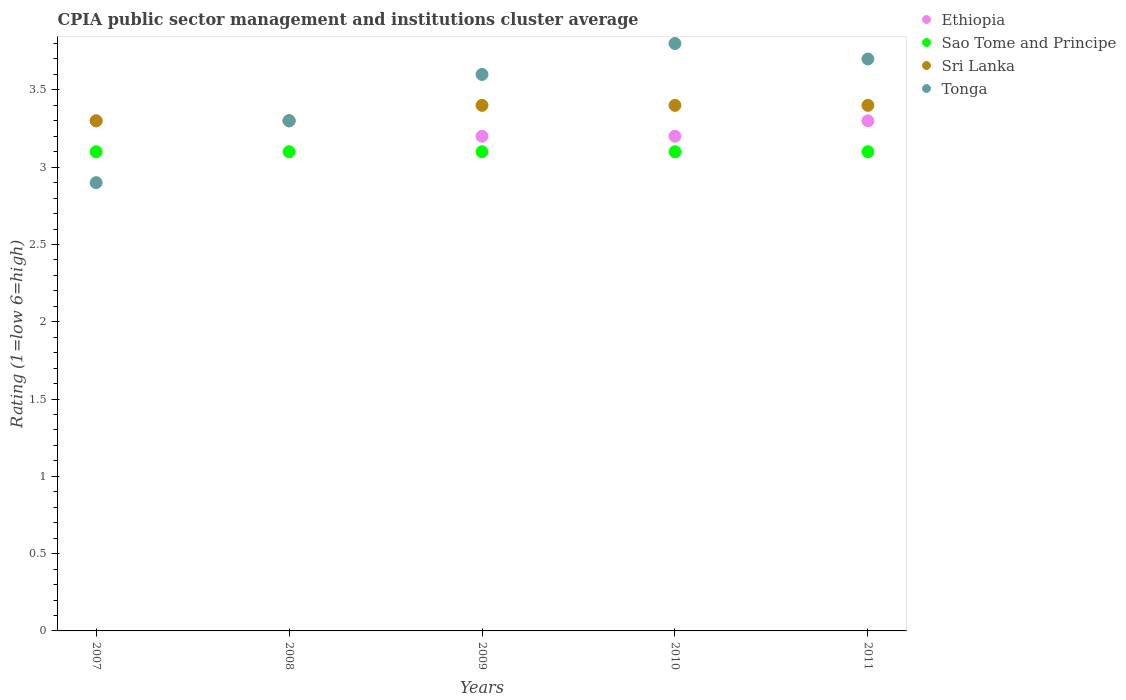How many different coloured dotlines are there?
Make the answer very short. 4. What is the CPIA rating in Sao Tome and Principe in 2007?
Make the answer very short. 3.1. Across all years, what is the maximum CPIA rating in Ethiopia?
Your response must be concise. 3.3. In which year was the CPIA rating in Sri Lanka maximum?
Provide a short and direct response. 2009. What is the difference between the CPIA rating in Sao Tome and Principe in 2010 and that in 2011?
Your answer should be compact. 0. What is the difference between the CPIA rating in Sri Lanka in 2010 and the CPIA rating in Sao Tome and Principe in 2007?
Provide a short and direct response. 0.3. What is the average CPIA rating in Tonga per year?
Offer a very short reply. 3.46. In the year 2007, what is the difference between the CPIA rating in Sao Tome and Principe and CPIA rating in Sri Lanka?
Your answer should be compact. -0.2. In how many years, is the CPIA rating in Sri Lanka greater than 1.4?
Give a very brief answer. 5. What is the ratio of the CPIA rating in Tonga in 2007 to that in 2009?
Offer a very short reply. 0.81. Is the CPIA rating in Sri Lanka in 2007 less than that in 2010?
Keep it short and to the point. Yes. What is the difference between the highest and the lowest CPIA rating in Ethiopia?
Your response must be concise. 0.1. Is the sum of the CPIA rating in Tonga in 2008 and 2011 greater than the maximum CPIA rating in Ethiopia across all years?
Your answer should be very brief. Yes. Is it the case that in every year, the sum of the CPIA rating in Sri Lanka and CPIA rating in Sao Tome and Principe  is greater than the CPIA rating in Tonga?
Keep it short and to the point. Yes. Is the CPIA rating in Ethiopia strictly greater than the CPIA rating in Sri Lanka over the years?
Keep it short and to the point. No. Is the CPIA rating in Sri Lanka strictly less than the CPIA rating in Tonga over the years?
Keep it short and to the point. No. How many dotlines are there?
Give a very brief answer. 4. What is the difference between two consecutive major ticks on the Y-axis?
Your response must be concise. 0.5. Where does the legend appear in the graph?
Make the answer very short. Top right. How are the legend labels stacked?
Your answer should be very brief. Vertical. What is the title of the graph?
Your answer should be very brief. CPIA public sector management and institutions cluster average. Does "Least developed countries" appear as one of the legend labels in the graph?
Make the answer very short. No. What is the Rating (1=low 6=high) in Tonga in 2007?
Provide a succinct answer. 2.9. What is the Rating (1=low 6=high) of Sri Lanka in 2008?
Make the answer very short. 3.3. What is the Rating (1=low 6=high) in Sri Lanka in 2009?
Your answer should be very brief. 3.4. What is the Rating (1=low 6=high) of Ethiopia in 2011?
Ensure brevity in your answer.  3.3. What is the Rating (1=low 6=high) of Sao Tome and Principe in 2011?
Offer a terse response. 3.1. Across all years, what is the maximum Rating (1=low 6=high) in Ethiopia?
Give a very brief answer. 3.3. Across all years, what is the maximum Rating (1=low 6=high) in Sao Tome and Principe?
Provide a short and direct response. 3.1. Across all years, what is the maximum Rating (1=low 6=high) of Sri Lanka?
Provide a succinct answer. 3.4. Across all years, what is the minimum Rating (1=low 6=high) of Ethiopia?
Make the answer very short. 3.2. Across all years, what is the minimum Rating (1=low 6=high) of Sao Tome and Principe?
Make the answer very short. 3.1. Across all years, what is the minimum Rating (1=low 6=high) of Sri Lanka?
Offer a terse response. 3.3. What is the total Rating (1=low 6=high) in Ethiopia in the graph?
Give a very brief answer. 16.3. What is the difference between the Rating (1=low 6=high) of Ethiopia in 2007 and that in 2008?
Offer a terse response. 0. What is the difference between the Rating (1=low 6=high) of Ethiopia in 2007 and that in 2009?
Your response must be concise. 0.1. What is the difference between the Rating (1=low 6=high) in Sao Tome and Principe in 2007 and that in 2009?
Make the answer very short. 0. What is the difference between the Rating (1=low 6=high) in Tonga in 2007 and that in 2009?
Provide a succinct answer. -0.7. What is the difference between the Rating (1=low 6=high) of Sri Lanka in 2007 and that in 2011?
Ensure brevity in your answer.  -0.1. What is the difference between the Rating (1=low 6=high) of Tonga in 2007 and that in 2011?
Offer a very short reply. -0.8. What is the difference between the Rating (1=low 6=high) in Ethiopia in 2008 and that in 2009?
Your answer should be very brief. 0.1. What is the difference between the Rating (1=low 6=high) in Sao Tome and Principe in 2008 and that in 2009?
Offer a terse response. 0. What is the difference between the Rating (1=low 6=high) of Sri Lanka in 2008 and that in 2009?
Ensure brevity in your answer.  -0.1. What is the difference between the Rating (1=low 6=high) in Tonga in 2008 and that in 2009?
Make the answer very short. -0.3. What is the difference between the Rating (1=low 6=high) in Sao Tome and Principe in 2008 and that in 2010?
Offer a terse response. 0. What is the difference between the Rating (1=low 6=high) of Sri Lanka in 2008 and that in 2011?
Your answer should be very brief. -0.1. What is the difference between the Rating (1=low 6=high) of Ethiopia in 2009 and that in 2010?
Your response must be concise. 0. What is the difference between the Rating (1=low 6=high) of Sao Tome and Principe in 2009 and that in 2010?
Offer a terse response. 0. What is the difference between the Rating (1=low 6=high) of Sri Lanka in 2009 and that in 2010?
Offer a terse response. 0. What is the difference between the Rating (1=low 6=high) of Tonga in 2009 and that in 2010?
Offer a very short reply. -0.2. What is the difference between the Rating (1=low 6=high) in Sri Lanka in 2009 and that in 2011?
Your answer should be very brief. 0. What is the difference between the Rating (1=low 6=high) of Sri Lanka in 2010 and that in 2011?
Your response must be concise. 0. What is the difference between the Rating (1=low 6=high) in Tonga in 2010 and that in 2011?
Provide a succinct answer. 0.1. What is the difference between the Rating (1=low 6=high) of Ethiopia in 2007 and the Rating (1=low 6=high) of Sri Lanka in 2008?
Give a very brief answer. 0. What is the difference between the Rating (1=low 6=high) in Sri Lanka in 2007 and the Rating (1=low 6=high) in Tonga in 2008?
Make the answer very short. 0. What is the difference between the Rating (1=low 6=high) in Ethiopia in 2007 and the Rating (1=low 6=high) in Sao Tome and Principe in 2009?
Your answer should be compact. 0.2. What is the difference between the Rating (1=low 6=high) of Ethiopia in 2007 and the Rating (1=low 6=high) of Sri Lanka in 2009?
Your answer should be compact. -0.1. What is the difference between the Rating (1=low 6=high) in Ethiopia in 2007 and the Rating (1=low 6=high) in Tonga in 2009?
Offer a very short reply. -0.3. What is the difference between the Rating (1=low 6=high) in Sao Tome and Principe in 2007 and the Rating (1=low 6=high) in Tonga in 2009?
Your answer should be very brief. -0.5. What is the difference between the Rating (1=low 6=high) in Ethiopia in 2007 and the Rating (1=low 6=high) in Sao Tome and Principe in 2010?
Your answer should be very brief. 0.2. What is the difference between the Rating (1=low 6=high) of Ethiopia in 2007 and the Rating (1=low 6=high) of Sri Lanka in 2010?
Your answer should be compact. -0.1. What is the difference between the Rating (1=low 6=high) of Ethiopia in 2007 and the Rating (1=low 6=high) of Sri Lanka in 2011?
Offer a very short reply. -0.1. What is the difference between the Rating (1=low 6=high) in Ethiopia in 2007 and the Rating (1=low 6=high) in Tonga in 2011?
Provide a succinct answer. -0.4. What is the difference between the Rating (1=low 6=high) of Sao Tome and Principe in 2007 and the Rating (1=low 6=high) of Sri Lanka in 2011?
Ensure brevity in your answer.  -0.3. What is the difference between the Rating (1=low 6=high) of Sao Tome and Principe in 2007 and the Rating (1=low 6=high) of Tonga in 2011?
Your answer should be very brief. -0.6. What is the difference between the Rating (1=low 6=high) in Ethiopia in 2008 and the Rating (1=low 6=high) in Sao Tome and Principe in 2009?
Offer a very short reply. 0.2. What is the difference between the Rating (1=low 6=high) in Ethiopia in 2008 and the Rating (1=low 6=high) in Sri Lanka in 2009?
Ensure brevity in your answer.  -0.1. What is the difference between the Rating (1=low 6=high) of Sao Tome and Principe in 2008 and the Rating (1=low 6=high) of Tonga in 2009?
Provide a short and direct response. -0.5. What is the difference between the Rating (1=low 6=high) in Sri Lanka in 2008 and the Rating (1=low 6=high) in Tonga in 2009?
Make the answer very short. -0.3. What is the difference between the Rating (1=low 6=high) of Ethiopia in 2008 and the Rating (1=low 6=high) of Sao Tome and Principe in 2010?
Give a very brief answer. 0.2. What is the difference between the Rating (1=low 6=high) in Ethiopia in 2008 and the Rating (1=low 6=high) in Sri Lanka in 2010?
Make the answer very short. -0.1. What is the difference between the Rating (1=low 6=high) in Ethiopia in 2008 and the Rating (1=low 6=high) in Tonga in 2010?
Give a very brief answer. -0.5. What is the difference between the Rating (1=low 6=high) in Sao Tome and Principe in 2008 and the Rating (1=low 6=high) in Sri Lanka in 2010?
Offer a very short reply. -0.3. What is the difference between the Rating (1=low 6=high) in Sao Tome and Principe in 2008 and the Rating (1=low 6=high) in Tonga in 2010?
Provide a short and direct response. -0.7. What is the difference between the Rating (1=low 6=high) in Ethiopia in 2008 and the Rating (1=low 6=high) in Sri Lanka in 2011?
Your answer should be very brief. -0.1. What is the difference between the Rating (1=low 6=high) in Ethiopia in 2008 and the Rating (1=low 6=high) in Tonga in 2011?
Provide a succinct answer. -0.4. What is the difference between the Rating (1=low 6=high) in Sri Lanka in 2008 and the Rating (1=low 6=high) in Tonga in 2011?
Ensure brevity in your answer.  -0.4. What is the difference between the Rating (1=low 6=high) of Sao Tome and Principe in 2009 and the Rating (1=low 6=high) of Sri Lanka in 2010?
Offer a very short reply. -0.3. What is the difference between the Rating (1=low 6=high) in Sao Tome and Principe in 2009 and the Rating (1=low 6=high) in Tonga in 2010?
Your response must be concise. -0.7. What is the difference between the Rating (1=low 6=high) in Sao Tome and Principe in 2009 and the Rating (1=low 6=high) in Tonga in 2011?
Provide a short and direct response. -0.6. What is the difference between the Rating (1=low 6=high) of Sri Lanka in 2009 and the Rating (1=low 6=high) of Tonga in 2011?
Offer a terse response. -0.3. What is the difference between the Rating (1=low 6=high) in Ethiopia in 2010 and the Rating (1=low 6=high) in Sri Lanka in 2011?
Offer a very short reply. -0.2. What is the average Rating (1=low 6=high) in Ethiopia per year?
Your answer should be very brief. 3.26. What is the average Rating (1=low 6=high) of Sri Lanka per year?
Provide a short and direct response. 3.36. What is the average Rating (1=low 6=high) in Tonga per year?
Ensure brevity in your answer.  3.46. In the year 2007, what is the difference between the Rating (1=low 6=high) in Ethiopia and Rating (1=low 6=high) in Sri Lanka?
Provide a short and direct response. 0. In the year 2007, what is the difference between the Rating (1=low 6=high) of Sao Tome and Principe and Rating (1=low 6=high) of Sri Lanka?
Your answer should be very brief. -0.2. In the year 2007, what is the difference between the Rating (1=low 6=high) in Sao Tome and Principe and Rating (1=low 6=high) in Tonga?
Provide a succinct answer. 0.2. In the year 2008, what is the difference between the Rating (1=low 6=high) of Ethiopia and Rating (1=low 6=high) of Sri Lanka?
Make the answer very short. 0. In the year 2008, what is the difference between the Rating (1=low 6=high) of Ethiopia and Rating (1=low 6=high) of Tonga?
Your answer should be compact. 0. In the year 2008, what is the difference between the Rating (1=low 6=high) of Sri Lanka and Rating (1=low 6=high) of Tonga?
Your answer should be compact. 0. In the year 2009, what is the difference between the Rating (1=low 6=high) of Ethiopia and Rating (1=low 6=high) of Tonga?
Offer a very short reply. -0.4. In the year 2009, what is the difference between the Rating (1=low 6=high) of Sao Tome and Principe and Rating (1=low 6=high) of Sri Lanka?
Make the answer very short. -0.3. In the year 2009, what is the difference between the Rating (1=low 6=high) in Sao Tome and Principe and Rating (1=low 6=high) in Tonga?
Provide a short and direct response. -0.5. In the year 2010, what is the difference between the Rating (1=low 6=high) of Ethiopia and Rating (1=low 6=high) of Sri Lanka?
Make the answer very short. -0.2. In the year 2010, what is the difference between the Rating (1=low 6=high) of Ethiopia and Rating (1=low 6=high) of Tonga?
Provide a short and direct response. -0.6. In the year 2010, what is the difference between the Rating (1=low 6=high) of Sao Tome and Principe and Rating (1=low 6=high) of Sri Lanka?
Make the answer very short. -0.3. In the year 2010, what is the difference between the Rating (1=low 6=high) in Sao Tome and Principe and Rating (1=low 6=high) in Tonga?
Offer a very short reply. -0.7. In the year 2011, what is the difference between the Rating (1=low 6=high) in Ethiopia and Rating (1=low 6=high) in Sao Tome and Principe?
Provide a short and direct response. 0.2. In the year 2011, what is the difference between the Rating (1=low 6=high) in Ethiopia and Rating (1=low 6=high) in Sri Lanka?
Offer a terse response. -0.1. What is the ratio of the Rating (1=low 6=high) in Ethiopia in 2007 to that in 2008?
Offer a terse response. 1. What is the ratio of the Rating (1=low 6=high) of Sao Tome and Principe in 2007 to that in 2008?
Provide a short and direct response. 1. What is the ratio of the Rating (1=low 6=high) in Sri Lanka in 2007 to that in 2008?
Give a very brief answer. 1. What is the ratio of the Rating (1=low 6=high) in Tonga in 2007 to that in 2008?
Provide a succinct answer. 0.88. What is the ratio of the Rating (1=low 6=high) in Ethiopia in 2007 to that in 2009?
Your answer should be compact. 1.03. What is the ratio of the Rating (1=low 6=high) of Sri Lanka in 2007 to that in 2009?
Make the answer very short. 0.97. What is the ratio of the Rating (1=low 6=high) of Tonga in 2007 to that in 2009?
Make the answer very short. 0.81. What is the ratio of the Rating (1=low 6=high) of Ethiopia in 2007 to that in 2010?
Offer a very short reply. 1.03. What is the ratio of the Rating (1=low 6=high) of Sao Tome and Principe in 2007 to that in 2010?
Your answer should be very brief. 1. What is the ratio of the Rating (1=low 6=high) in Sri Lanka in 2007 to that in 2010?
Provide a short and direct response. 0.97. What is the ratio of the Rating (1=low 6=high) in Tonga in 2007 to that in 2010?
Provide a succinct answer. 0.76. What is the ratio of the Rating (1=low 6=high) in Sri Lanka in 2007 to that in 2011?
Give a very brief answer. 0.97. What is the ratio of the Rating (1=low 6=high) in Tonga in 2007 to that in 2011?
Provide a short and direct response. 0.78. What is the ratio of the Rating (1=low 6=high) of Ethiopia in 2008 to that in 2009?
Ensure brevity in your answer.  1.03. What is the ratio of the Rating (1=low 6=high) in Sao Tome and Principe in 2008 to that in 2009?
Your response must be concise. 1. What is the ratio of the Rating (1=low 6=high) of Sri Lanka in 2008 to that in 2009?
Your response must be concise. 0.97. What is the ratio of the Rating (1=low 6=high) of Tonga in 2008 to that in 2009?
Ensure brevity in your answer.  0.92. What is the ratio of the Rating (1=low 6=high) of Ethiopia in 2008 to that in 2010?
Your response must be concise. 1.03. What is the ratio of the Rating (1=low 6=high) in Sao Tome and Principe in 2008 to that in 2010?
Provide a short and direct response. 1. What is the ratio of the Rating (1=low 6=high) of Sri Lanka in 2008 to that in 2010?
Make the answer very short. 0.97. What is the ratio of the Rating (1=low 6=high) of Tonga in 2008 to that in 2010?
Ensure brevity in your answer.  0.87. What is the ratio of the Rating (1=low 6=high) of Sao Tome and Principe in 2008 to that in 2011?
Offer a very short reply. 1. What is the ratio of the Rating (1=low 6=high) in Sri Lanka in 2008 to that in 2011?
Give a very brief answer. 0.97. What is the ratio of the Rating (1=low 6=high) of Tonga in 2008 to that in 2011?
Give a very brief answer. 0.89. What is the ratio of the Rating (1=low 6=high) in Sao Tome and Principe in 2009 to that in 2010?
Provide a short and direct response. 1. What is the ratio of the Rating (1=low 6=high) of Sri Lanka in 2009 to that in 2010?
Your answer should be very brief. 1. What is the ratio of the Rating (1=low 6=high) in Tonga in 2009 to that in 2010?
Provide a succinct answer. 0.95. What is the ratio of the Rating (1=low 6=high) in Ethiopia in 2009 to that in 2011?
Offer a terse response. 0.97. What is the ratio of the Rating (1=low 6=high) of Sao Tome and Principe in 2009 to that in 2011?
Your answer should be compact. 1. What is the ratio of the Rating (1=low 6=high) of Tonga in 2009 to that in 2011?
Offer a terse response. 0.97. What is the ratio of the Rating (1=low 6=high) of Ethiopia in 2010 to that in 2011?
Your answer should be compact. 0.97. What is the difference between the highest and the second highest Rating (1=low 6=high) of Ethiopia?
Your answer should be very brief. 0. What is the difference between the highest and the second highest Rating (1=low 6=high) of Sao Tome and Principe?
Offer a very short reply. 0. What is the difference between the highest and the second highest Rating (1=low 6=high) of Sri Lanka?
Provide a short and direct response. 0. What is the difference between the highest and the lowest Rating (1=low 6=high) of Ethiopia?
Your answer should be very brief. 0.1. What is the difference between the highest and the lowest Rating (1=low 6=high) of Sao Tome and Principe?
Keep it short and to the point. 0. What is the difference between the highest and the lowest Rating (1=low 6=high) of Sri Lanka?
Your response must be concise. 0.1. What is the difference between the highest and the lowest Rating (1=low 6=high) of Tonga?
Keep it short and to the point. 0.9. 